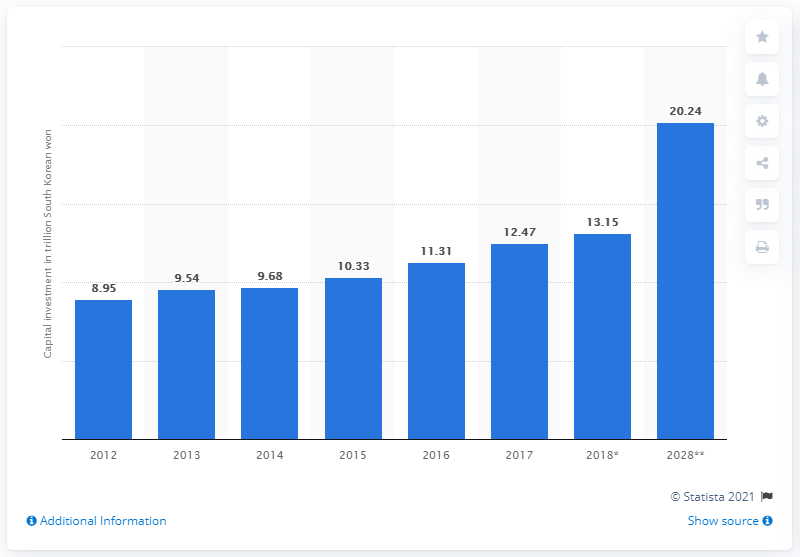Identify some key points in this picture. According to the forecast, South Korea's capital investment in the travel and tourism sector is expected to reach 20.24 billion U.S. dollars by 2028. 